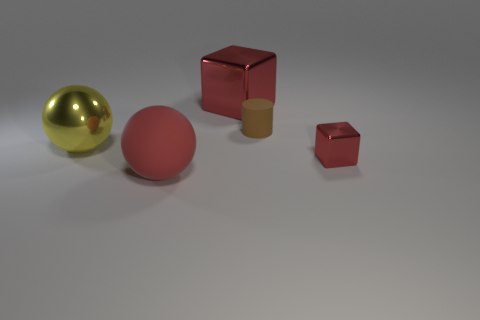Add 2 yellow shiny balls. How many objects exist? 7 Subtract all blocks. How many objects are left? 3 Add 3 tiny red shiny objects. How many tiny red shiny objects are left? 4 Add 4 brown objects. How many brown objects exist? 5 Subtract 0 blue cylinders. How many objects are left? 5 Subtract all big cubes. Subtract all large cubes. How many objects are left? 3 